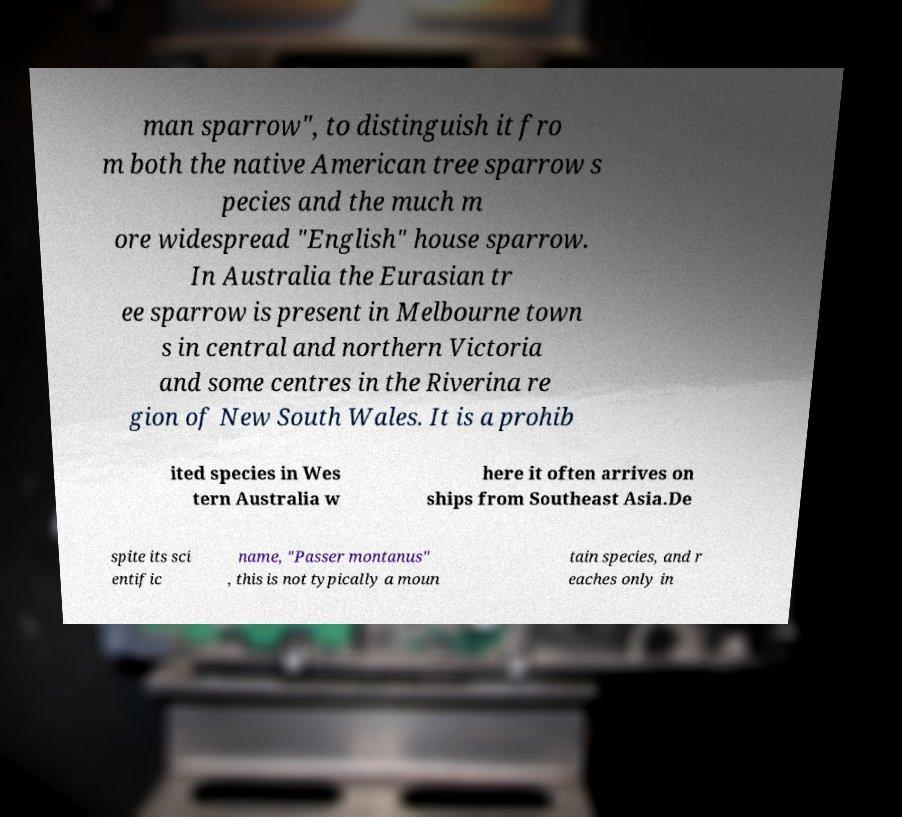For documentation purposes, I need the text within this image transcribed. Could you provide that? man sparrow", to distinguish it fro m both the native American tree sparrow s pecies and the much m ore widespread "English" house sparrow. In Australia the Eurasian tr ee sparrow is present in Melbourne town s in central and northern Victoria and some centres in the Riverina re gion of New South Wales. It is a prohib ited species in Wes tern Australia w here it often arrives on ships from Southeast Asia.De spite its sci entific name, "Passer montanus" , this is not typically a moun tain species, and r eaches only in 